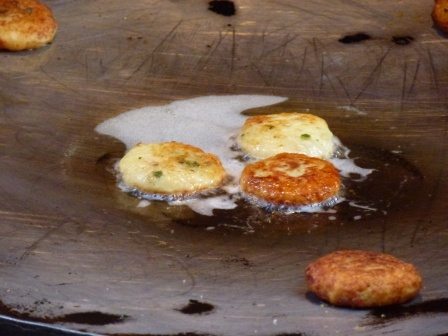If you were to give this scene a title, what would it be? Golden Morning Bliss: A Symphony of Pancakes in Progress 